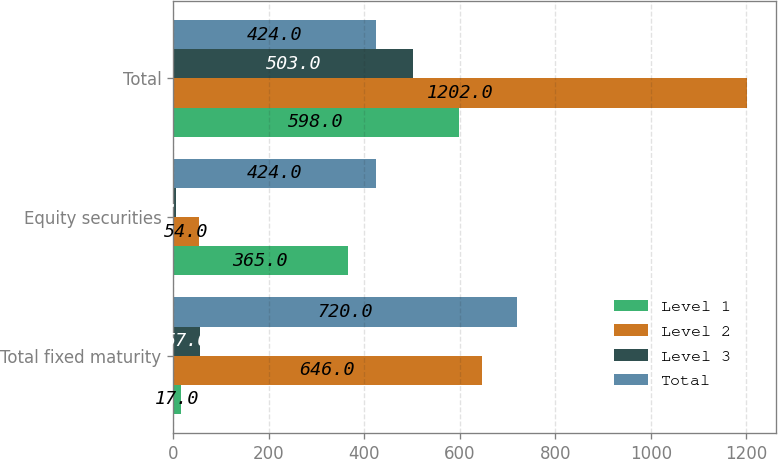<chart> <loc_0><loc_0><loc_500><loc_500><stacked_bar_chart><ecel><fcel>Total fixed maturity<fcel>Equity securities<fcel>Total<nl><fcel>Level 1<fcel>17<fcel>365<fcel>598<nl><fcel>Level 2<fcel>646<fcel>54<fcel>1202<nl><fcel>Level 3<fcel>57<fcel>5<fcel>503<nl><fcel>Total<fcel>720<fcel>424<fcel>424<nl></chart> 